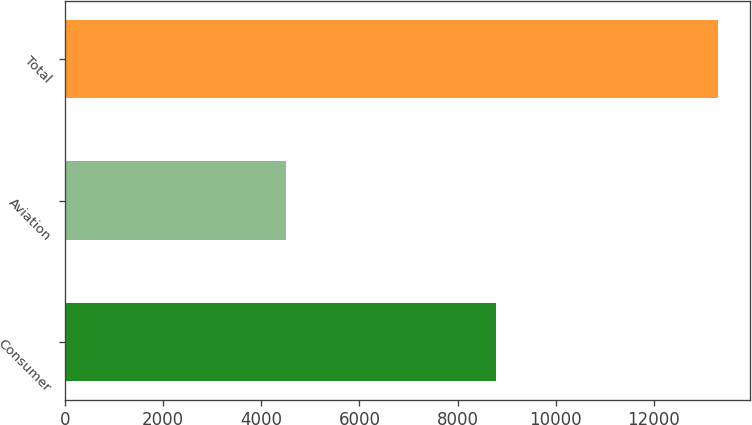Convert chart to OTSL. <chart><loc_0><loc_0><loc_500><loc_500><bar_chart><fcel>Consumer<fcel>Aviation<fcel>Total<nl><fcel>8792<fcel>4507<fcel>13299<nl></chart> 